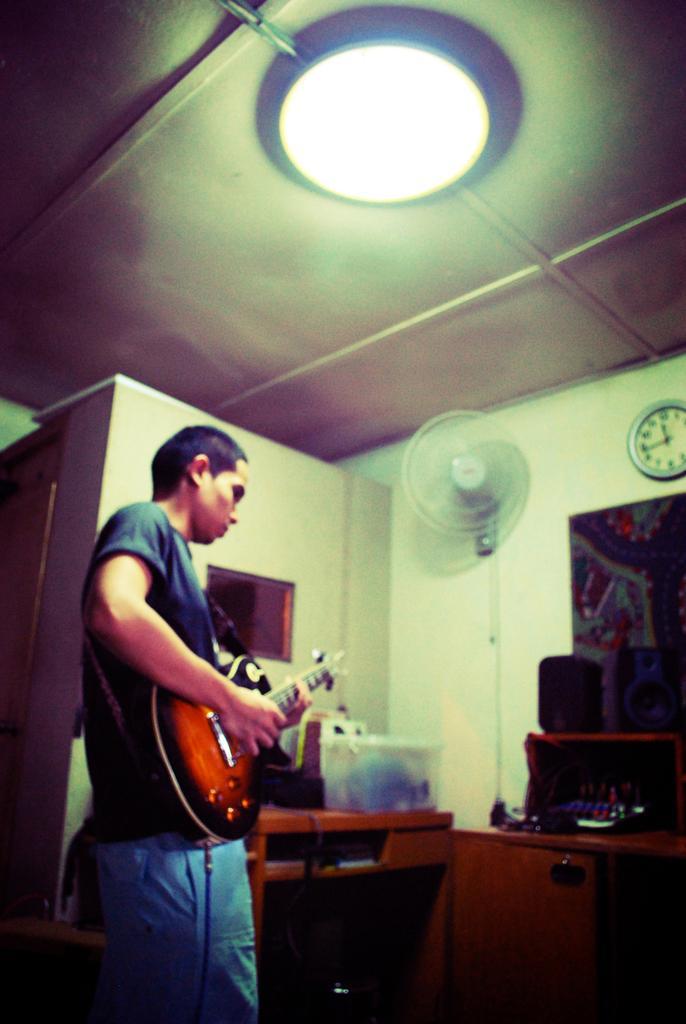How would you summarize this image in a sentence or two? In this picture we can see a man playing guitar. This is the light and there is a table. Here we can see a fan on to the wall and this is the clock. 